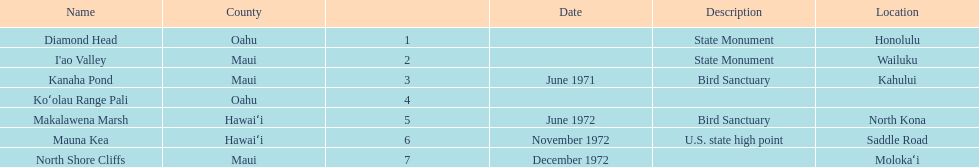Which county is featured the most on the chart? Maui. 